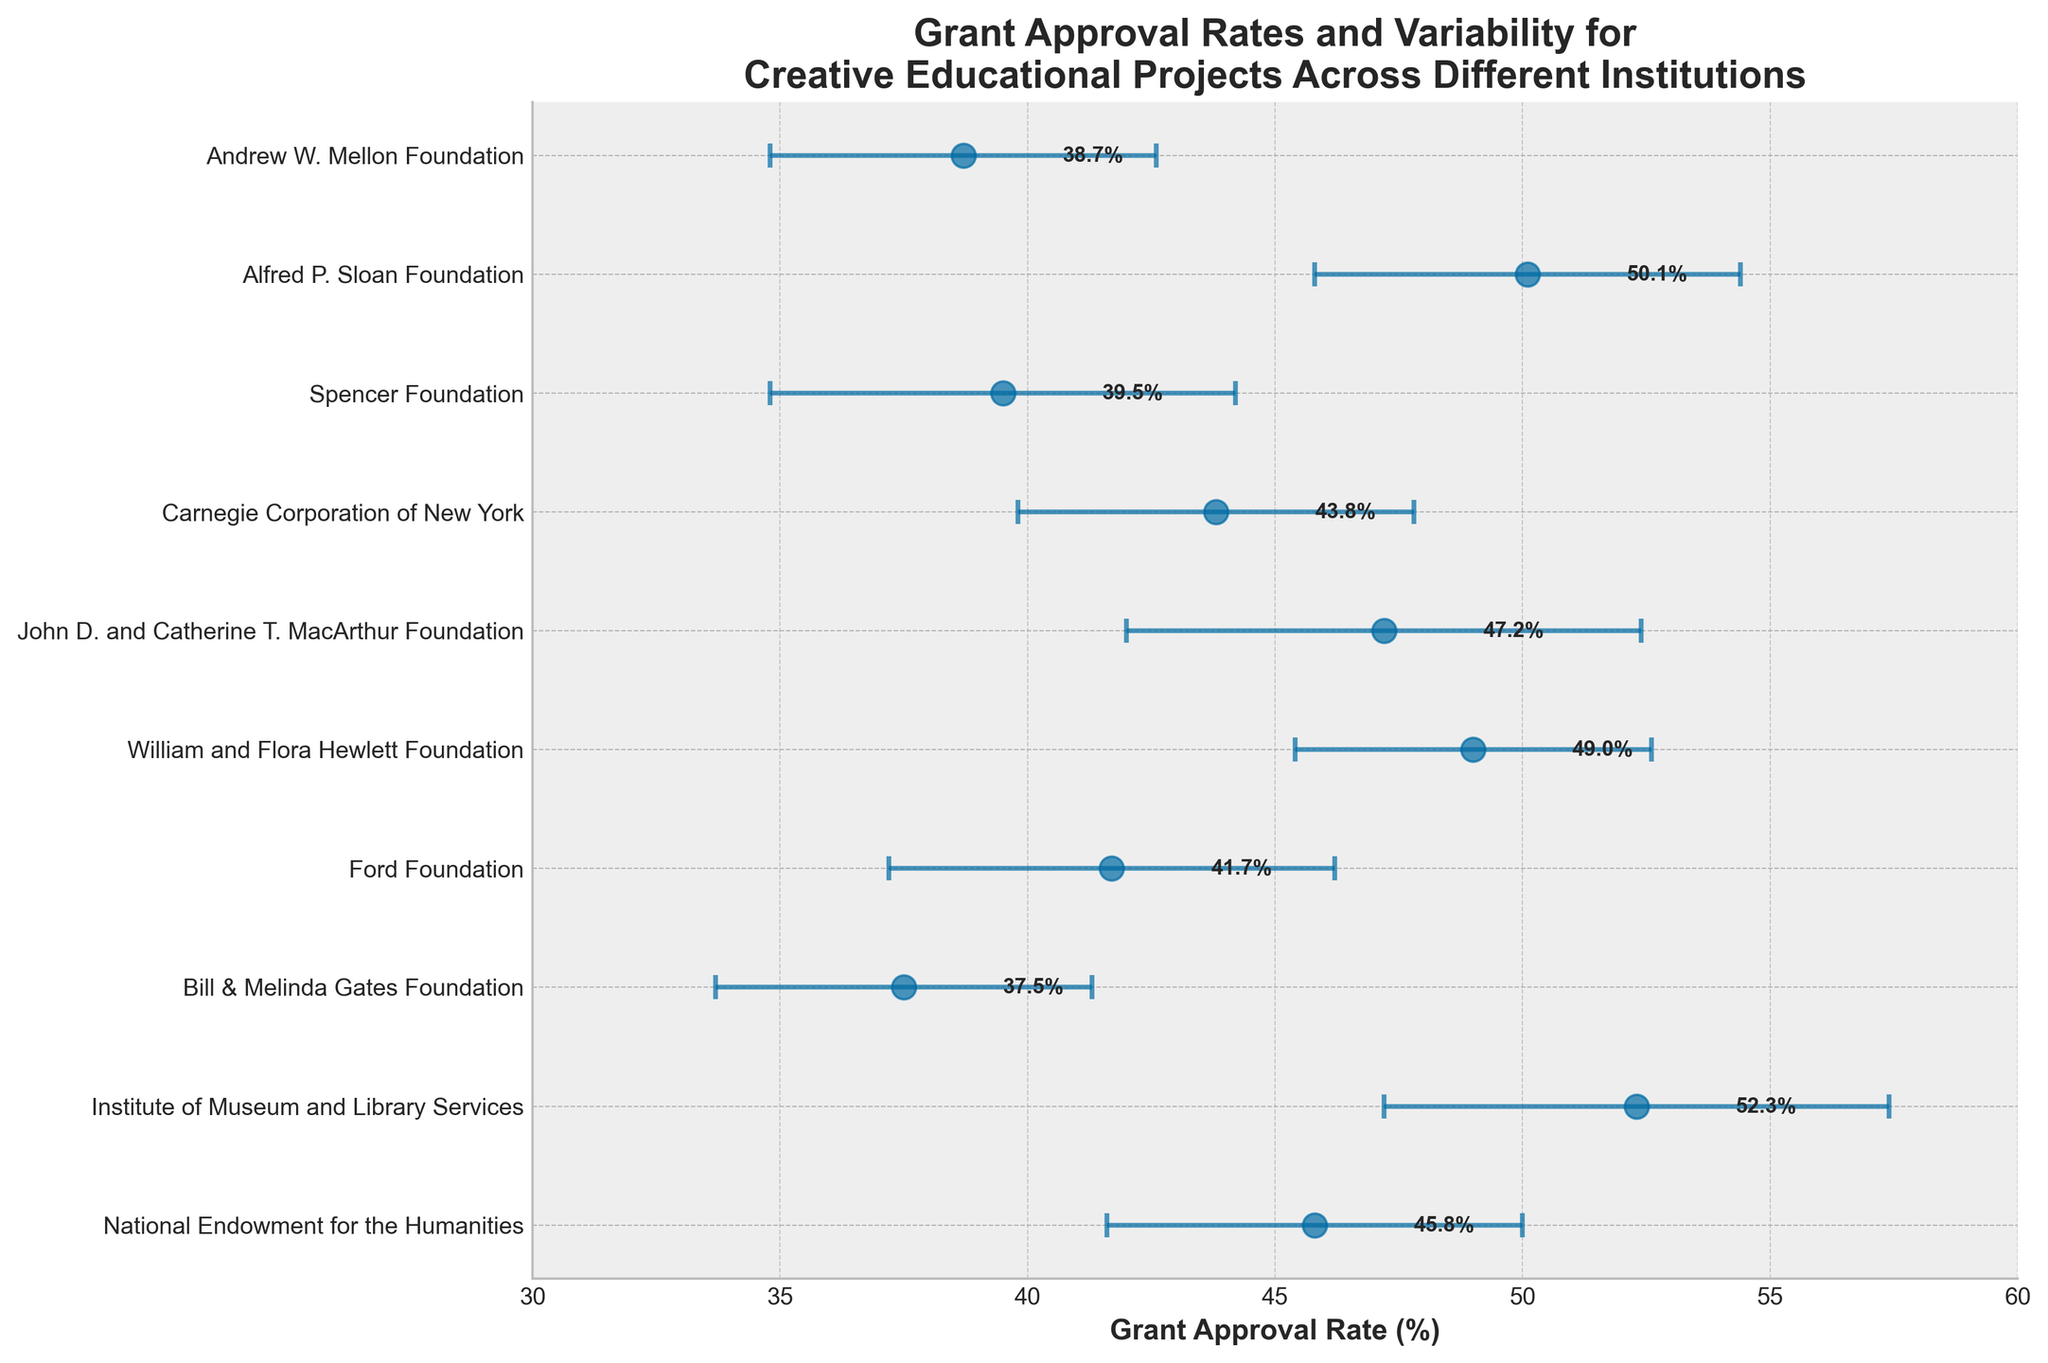What's the highest grant approval rate displayed? The highest grant approval rate can be found by looking at the dots on the plot and identifying the one that is furthest to the right on the x-axis. The Bill & Melinda Gates Foundation has an approval rate of 52.3%.
Answer: 52.3% Which institution has the lowest approval rate? The lowest approval rate is identified by finding the dot that is furthest to the left on the x-axis. The Bill & Melinda Gates Foundation has an approval rate of 37.5%.
Answer: 37.5% What is the title of the plot? The title of the plot is always located at the top center of the figure outlining the main theme or topic of the data shown. Here, it reads: "Grant Approval Rates and Variability for Creative Educational Projects Across Different Institutions".
Answer: Grant Approval Rates and Variability for Creative Educational Projects Across Different Institutions Which two institutions have the most similar approval rates? By comparing the positions of the dots on the plot, the two institutions with the most similar approval rates can be identified. The John D. and Catherine T. MacArthur Foundation and the National Endowment for the Humanities have very close approval rates at 47.2% and 45.8% respectively.
Answer: John D. and Catherine T. MacArthur Foundation and National Endowment for the Humanities Which institution has the greatest variability in its approval rate? The variability in approval rates is represented by the length of the error bars. The longest error bar belongs to the John D. and Catherine T. MacArthur Foundation with a standard deviation of 5.2%.
Answer: John D. and Catherine T. MacArthur Foundation What is the average of the approval rates for the institutions listed? To find the average approval rate, sum all the approval rates and divide by the number of institutions. The calculation is (45.8 + 52.3 + 37.5 + 41.7 + 49.0 + 47.2 + 43.8 + 39.5 + 50.1 + 38.7) / 10 = 445.6 / 10 = 44.56%.
Answer: 44.56% How does the approval rate for the Spencer Foundation compare to that of the Alfred P. Sloan Foundation? The Spencer Foundation has an approval rate of 39.5%, while the Alfred P. Sloan Foundation has an approval rate of 50.1%. Therefore, the Alfred P. Sloan Foundation has a higher approval rate.
Answer: The Alfred P. Sloan Foundation is higher Which institution has an approval rate of approximately 50% but with relatively lower variability? Checking the institutions with approval rates around 50% and then comparing their error bars for variability, the William and Flora Hewlett Foundation stands out with an approval rate of 49.0% and a standard deviation of 3.6%.
Answer: William and Flora Hewlett Foundation Which two institutions have approval rates below 40%? By identifying the dots below the 40% mark on the x-axis, the institutions are the Bill & Melinda Gates Foundation (37.5%) and the Andrew W. Mellon Foundation (38.7%).
Answer: Bill & Melinda Gates Foundation and Andrew W. Mellon Foundation What can be inferred from the variability in the approval rates across different institutions? The variability, represented by the length of the error bars, indicates the level of consistency or uncertainty in the approval rates. Institutions with longer error bars have more variability, suggesting fluctuating approval rates, while shorter bars indicate more consistent approval rates. The John D. and Catherine T. MacArthur Foundation shows the greatest variability, while the William and Flora Hewlett Foundation shows relatively low variability.
Answer: Institutions show varying degrees of consistency in approval rates== 